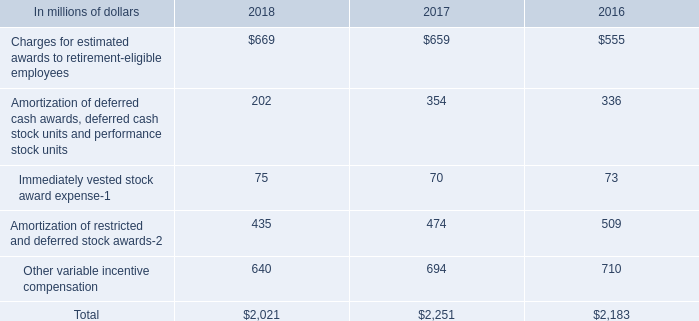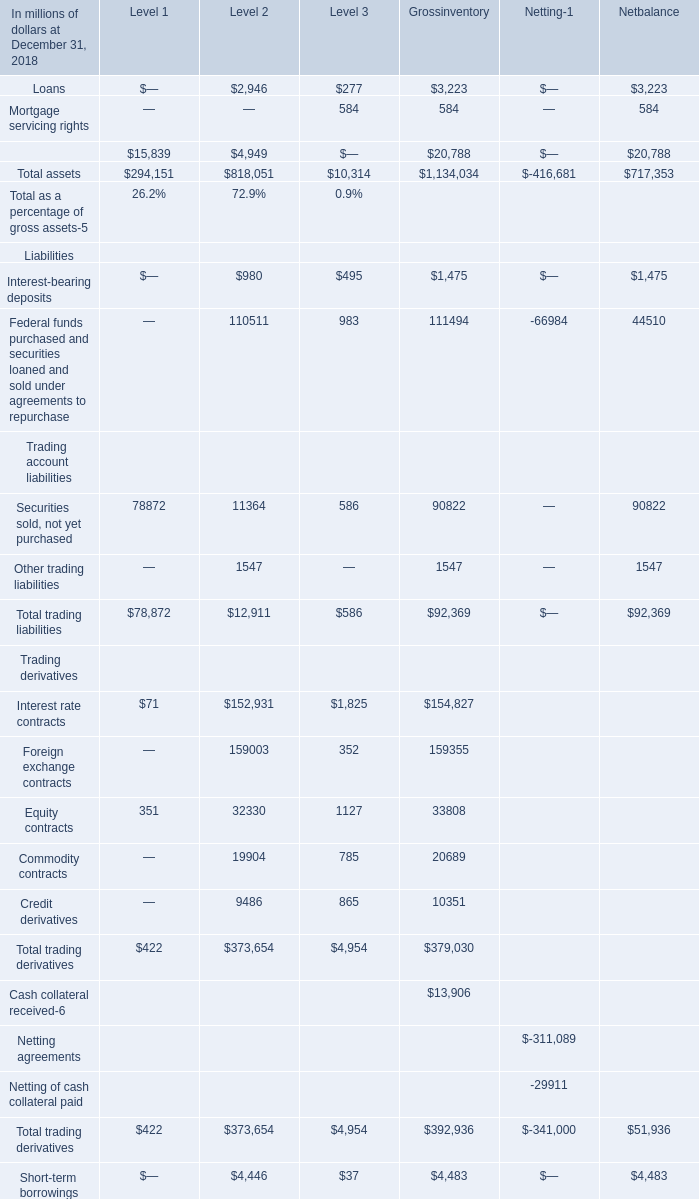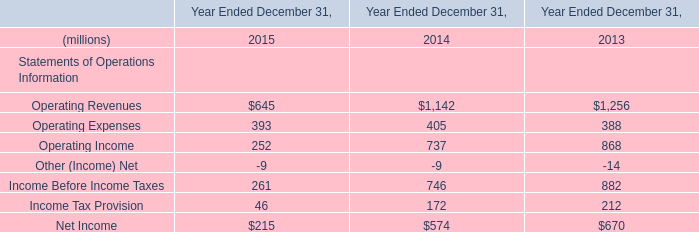What is the proportion of Non-trading derivatives and other financial assets measured on a recurring basis to the total in 2018? 
Computations: (15839 / 294151)
Answer: 0.05385. 